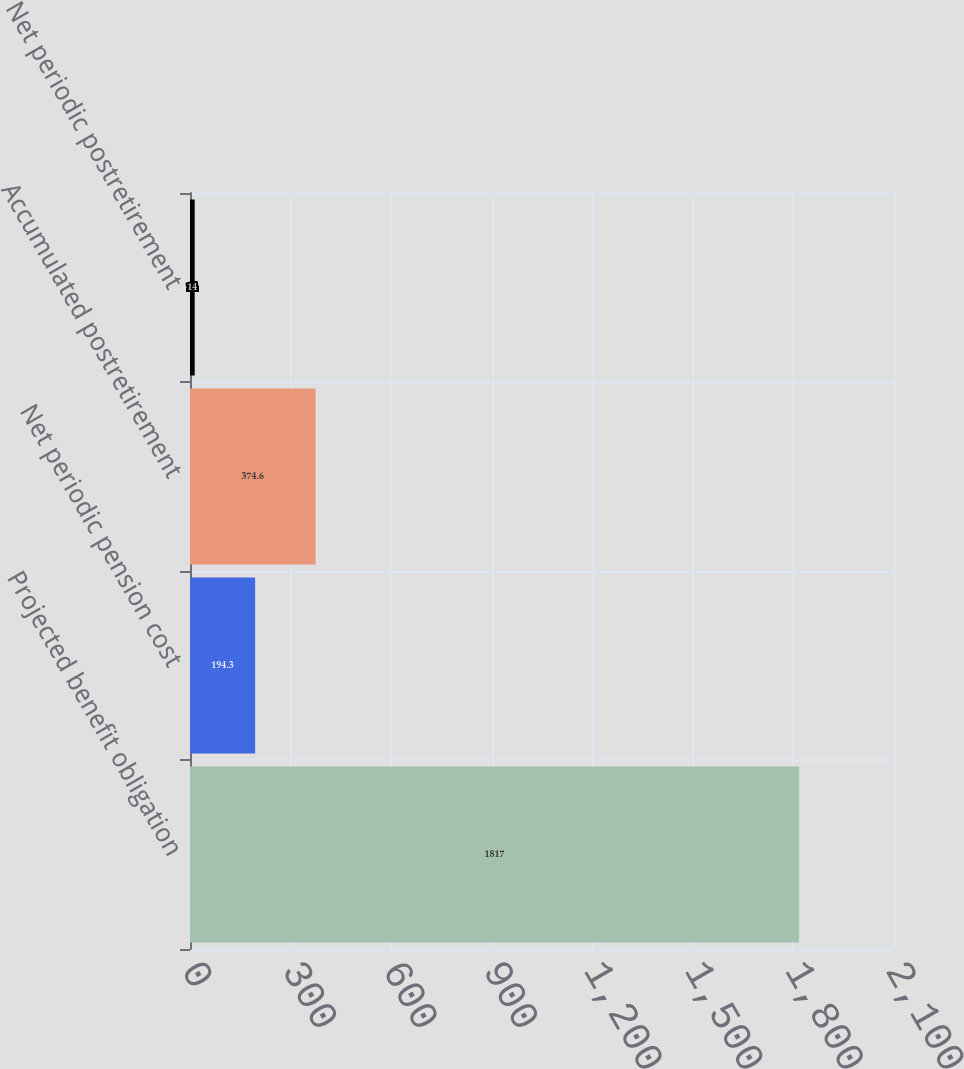Convert chart to OTSL. <chart><loc_0><loc_0><loc_500><loc_500><bar_chart><fcel>Projected benefit obligation<fcel>Net periodic pension cost<fcel>Accumulated postretirement<fcel>Net periodic postretirement<nl><fcel>1817<fcel>194.3<fcel>374.6<fcel>14<nl></chart> 